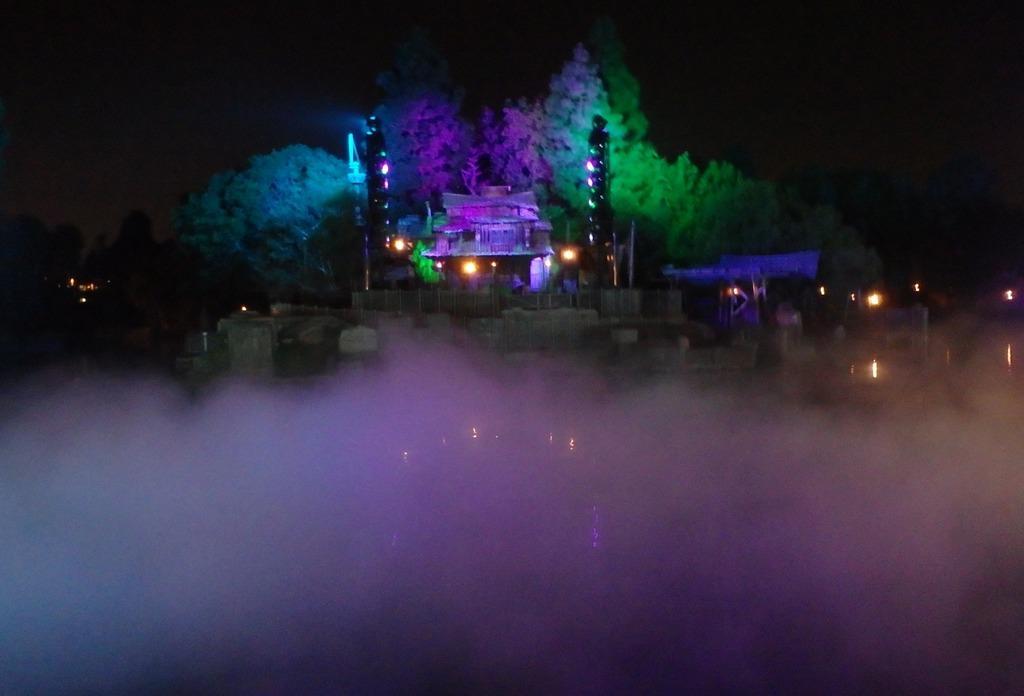Can you describe this image briefly? In the middle of the picture, we see the buildings, street lights and poles. There are trees, street lights and poles in the background. In front of the picture, we see the smoke. At the top, we see the sky, which is black in color. This picture is clicked in the dark. 